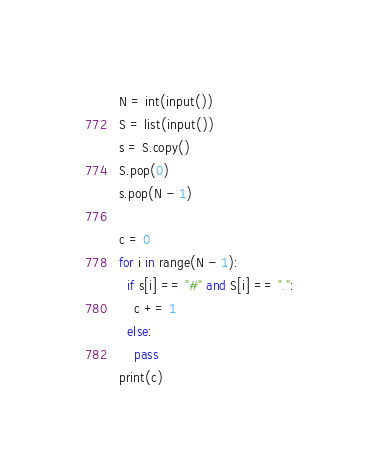Convert code to text. <code><loc_0><loc_0><loc_500><loc_500><_Python_>N = int(input())
S = list(input())
s = S.copy()
S.pop(0)
s.pop(N - 1)
 
c = 0
for i in range(N - 1):
  if s[i] == "#" and S[i] == ".":
    c += 1
  else:
    pass
print(c)</code> 